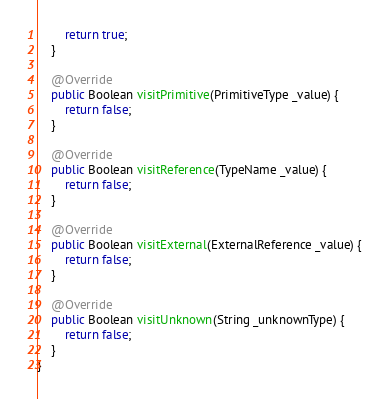Convert code to text. <code><loc_0><loc_0><loc_500><loc_500><_Java_>        return true;
    }

    @Override
    public Boolean visitPrimitive(PrimitiveType _value) {
        return false;
    }

    @Override
    public Boolean visitReference(TypeName _value) {
        return false;
    }

    @Override
    public Boolean visitExternal(ExternalReference _value) {
        return false;
    }

    @Override
    public Boolean visitUnknown(String _unknownType) {
        return false;
    }
}
</code> 